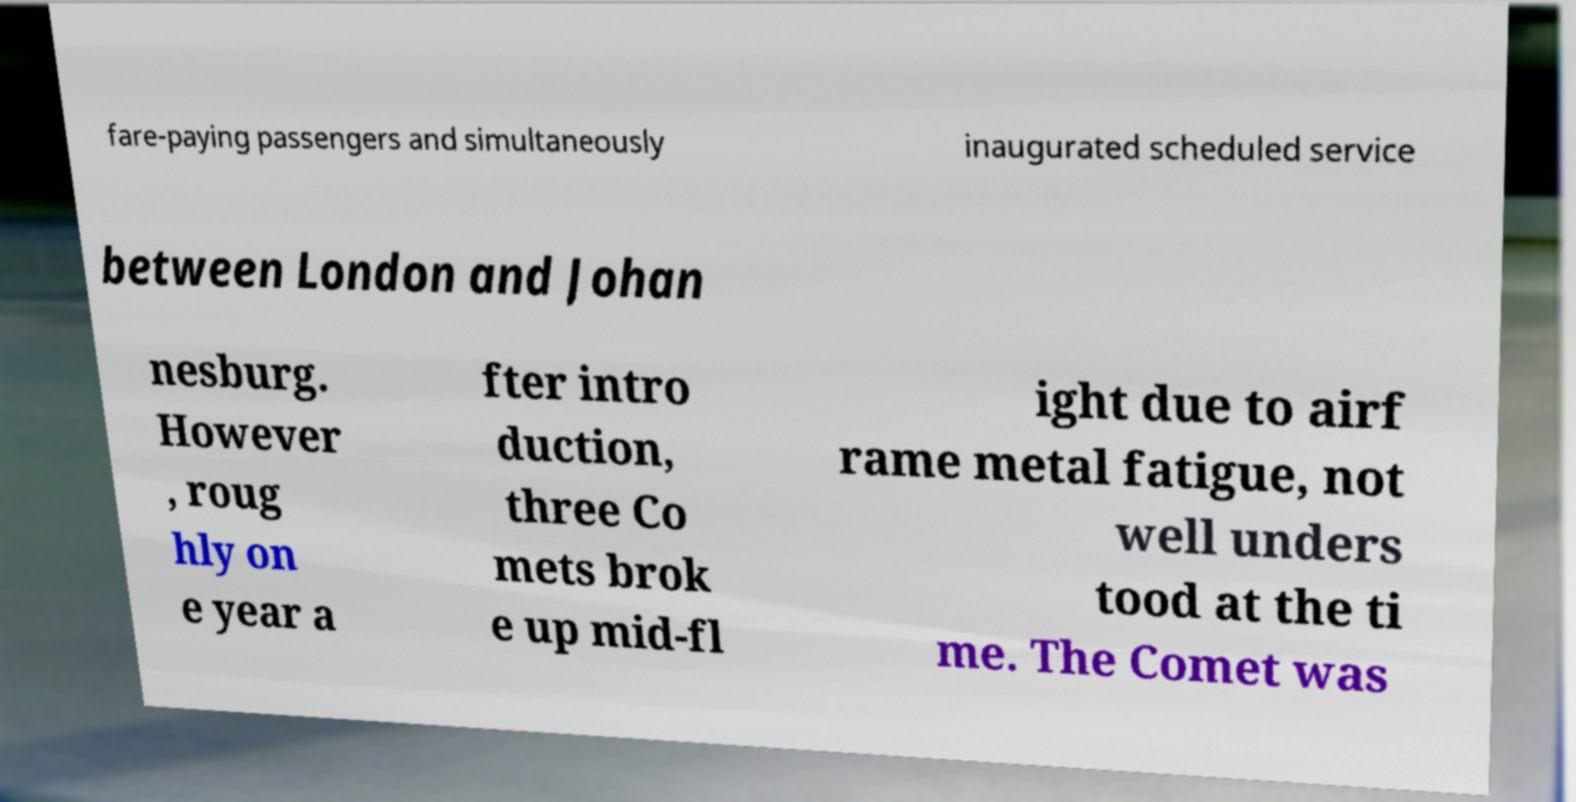I need the written content from this picture converted into text. Can you do that? fare-paying passengers and simultaneously inaugurated scheduled service between London and Johan nesburg. However , roug hly on e year a fter intro duction, three Co mets brok e up mid-fl ight due to airf rame metal fatigue, not well unders tood at the ti me. The Comet was 